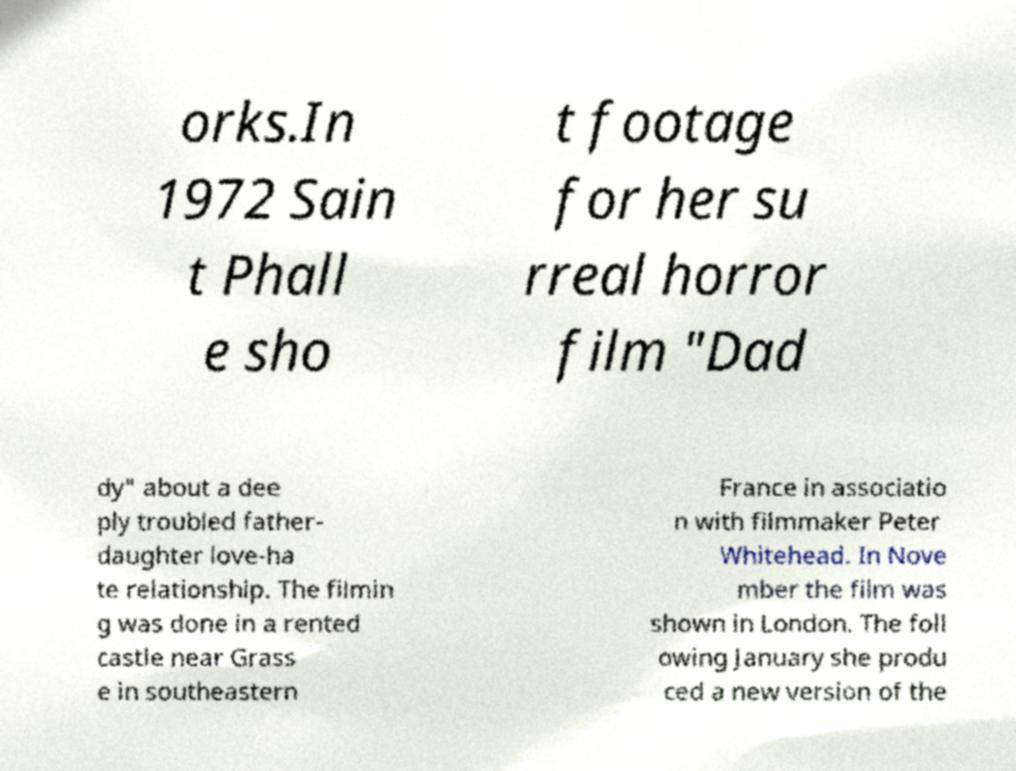Can you accurately transcribe the text from the provided image for me? orks.In 1972 Sain t Phall e sho t footage for her su rreal horror film "Dad dy" about a dee ply troubled father- daughter love-ha te relationship. The filmin g was done in a rented castle near Grass e in southeastern France in associatio n with filmmaker Peter Whitehead. In Nove mber the film was shown in London. The foll owing January she produ ced a new version of the 